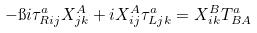<formula> <loc_0><loc_0><loc_500><loc_500>- \i i \tau ^ { a } _ { R i j } X _ { j k } ^ { A } + i X _ { i j } ^ { A } \tau ^ { a } _ { L j k } = X _ { i k } ^ { B } T ^ { a } _ { B A }</formula> 